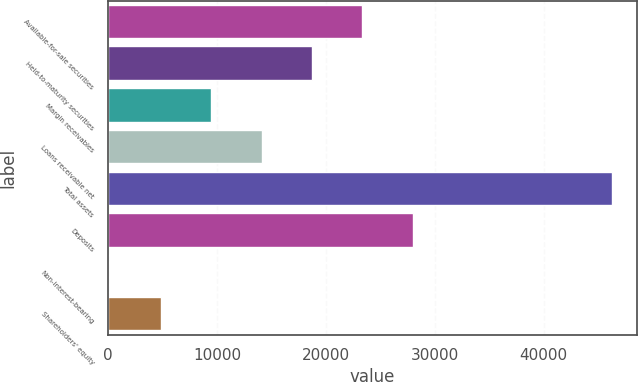Convert chart. <chart><loc_0><loc_0><loc_500><loc_500><bar_chart><fcel>Available-for-sale securities<fcel>Held-to-maturity securities<fcel>Margin receivables<fcel>Loans receivable net<fcel>Total assets<fcel>Deposits<fcel>Non-interest-bearing<fcel>Shareholders' equity<nl><fcel>23351.2<fcel>18727.4<fcel>9479.8<fcel>14103.6<fcel>46280<fcel>27975<fcel>42<fcel>4856<nl></chart> 